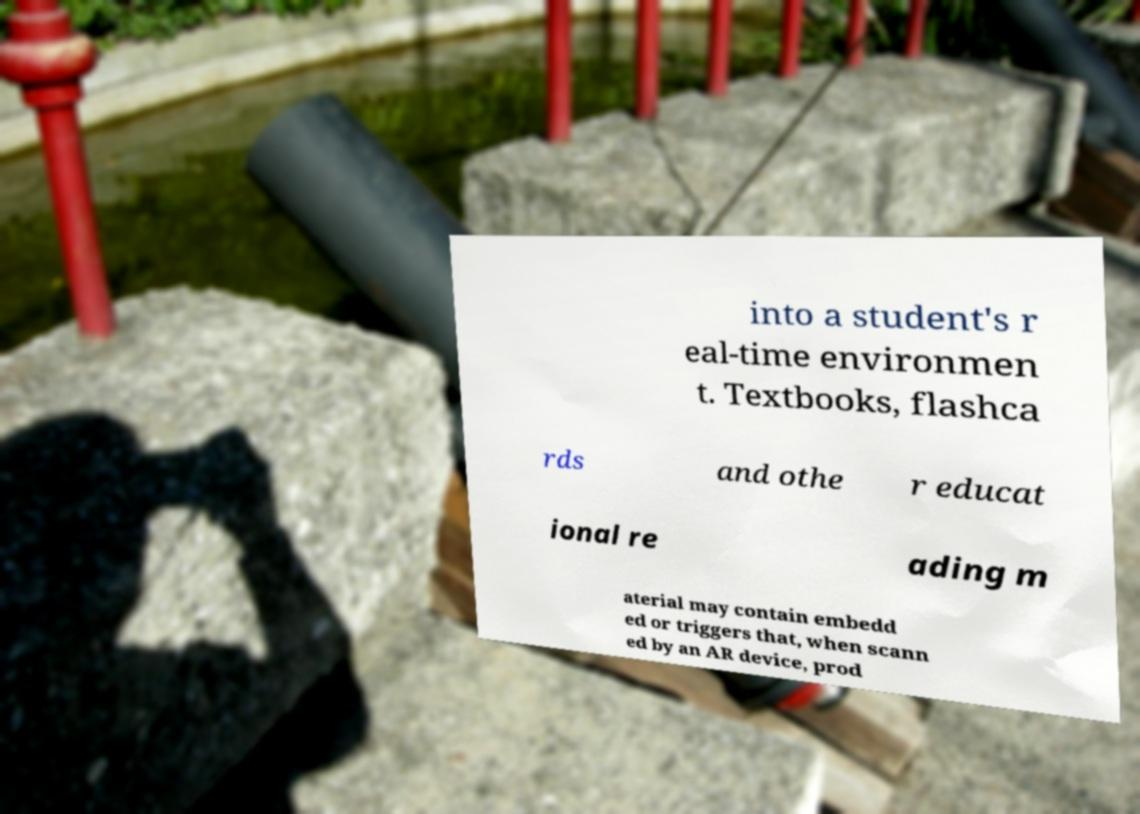Can you read and provide the text displayed in the image?This photo seems to have some interesting text. Can you extract and type it out for me? into a student's r eal-time environmen t. Textbooks, flashca rds and othe r educat ional re ading m aterial may contain embedd ed or triggers that, when scann ed by an AR device, prod 